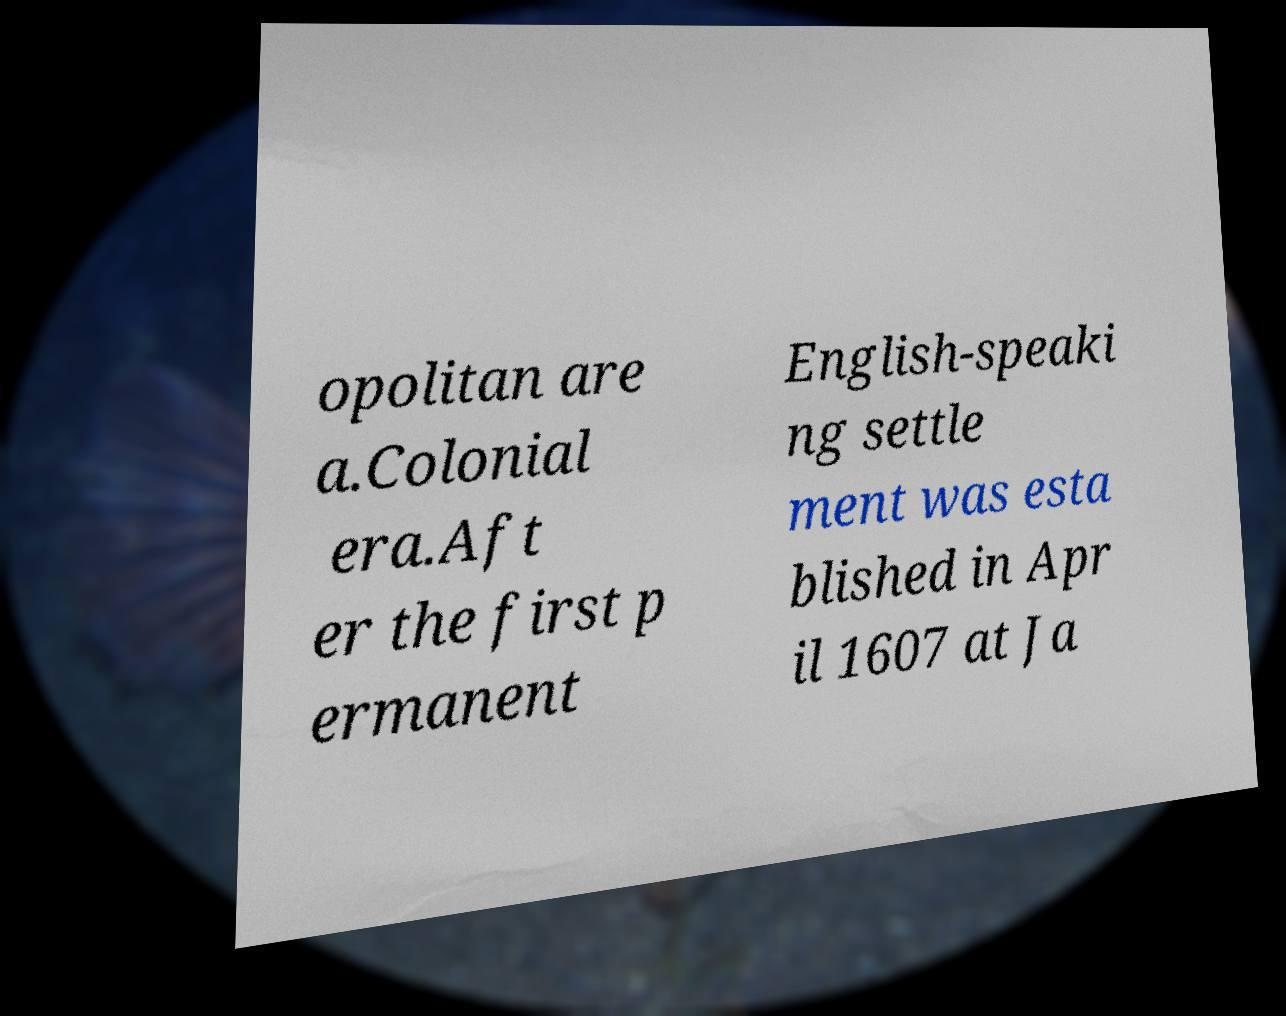Please read and relay the text visible in this image. What does it say? opolitan are a.Colonial era.Aft er the first p ermanent English-speaki ng settle ment was esta blished in Apr il 1607 at Ja 